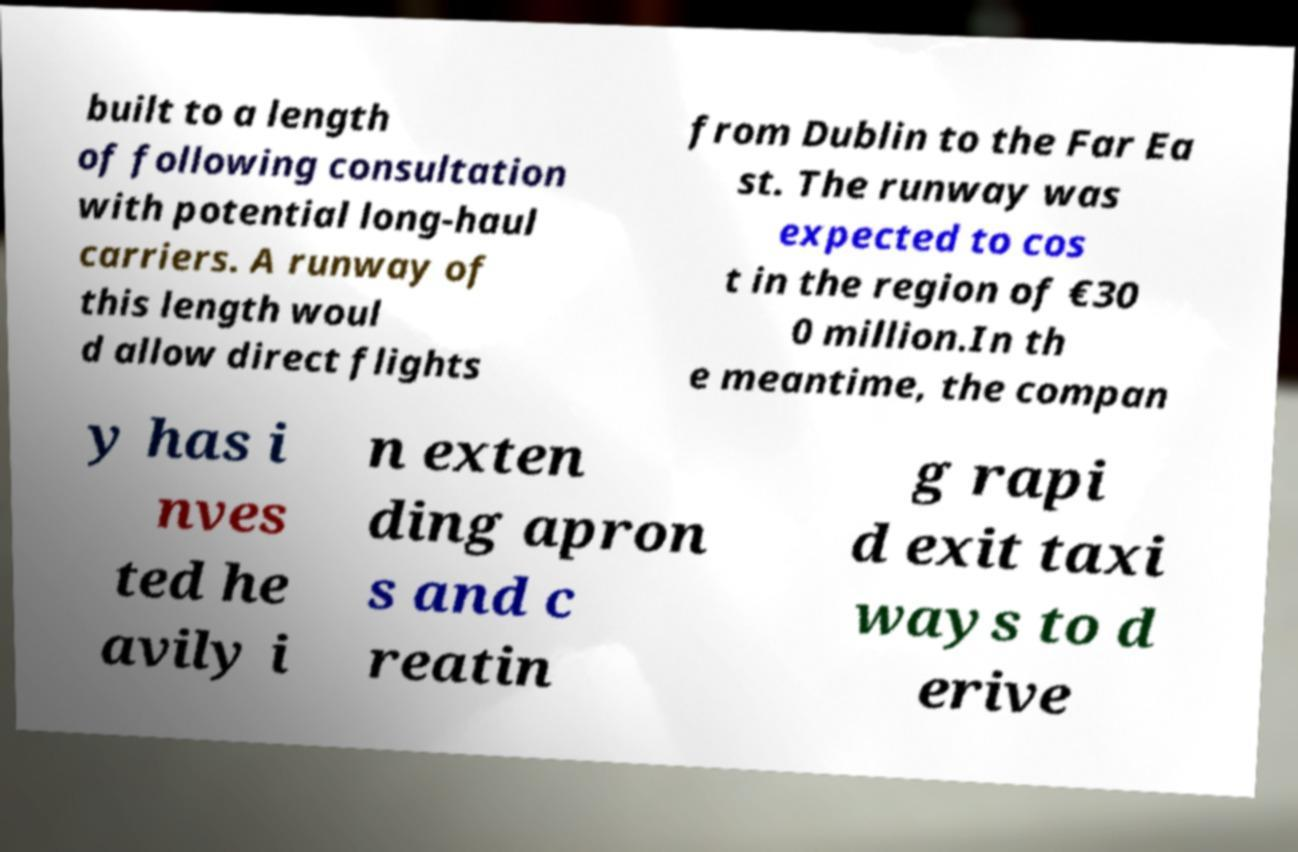Please read and relay the text visible in this image. What does it say? built to a length of following consultation with potential long-haul carriers. A runway of this length woul d allow direct flights from Dublin to the Far Ea st. The runway was expected to cos t in the region of €30 0 million.In th e meantime, the compan y has i nves ted he avily i n exten ding apron s and c reatin g rapi d exit taxi ways to d erive 